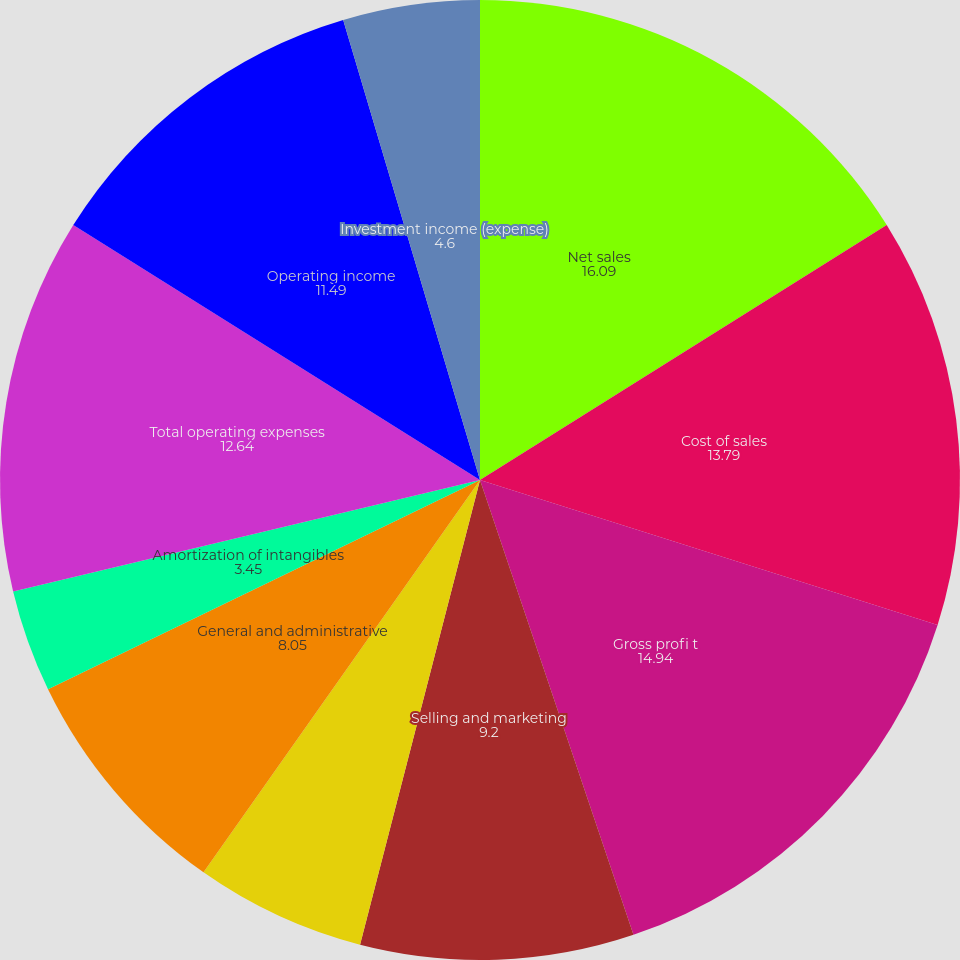Convert chart. <chart><loc_0><loc_0><loc_500><loc_500><pie_chart><fcel>Net sales<fcel>Cost of sales<fcel>Gross profi t<fcel>Selling and marketing<fcel>Research and engineering<fcel>General and administrative<fcel>Amortization of intangibles<fcel>Total operating expenses<fcel>Operating income<fcel>Investment income (expense)<nl><fcel>16.09%<fcel>13.79%<fcel>14.94%<fcel>9.2%<fcel>5.75%<fcel>8.05%<fcel>3.45%<fcel>12.64%<fcel>11.49%<fcel>4.6%<nl></chart> 